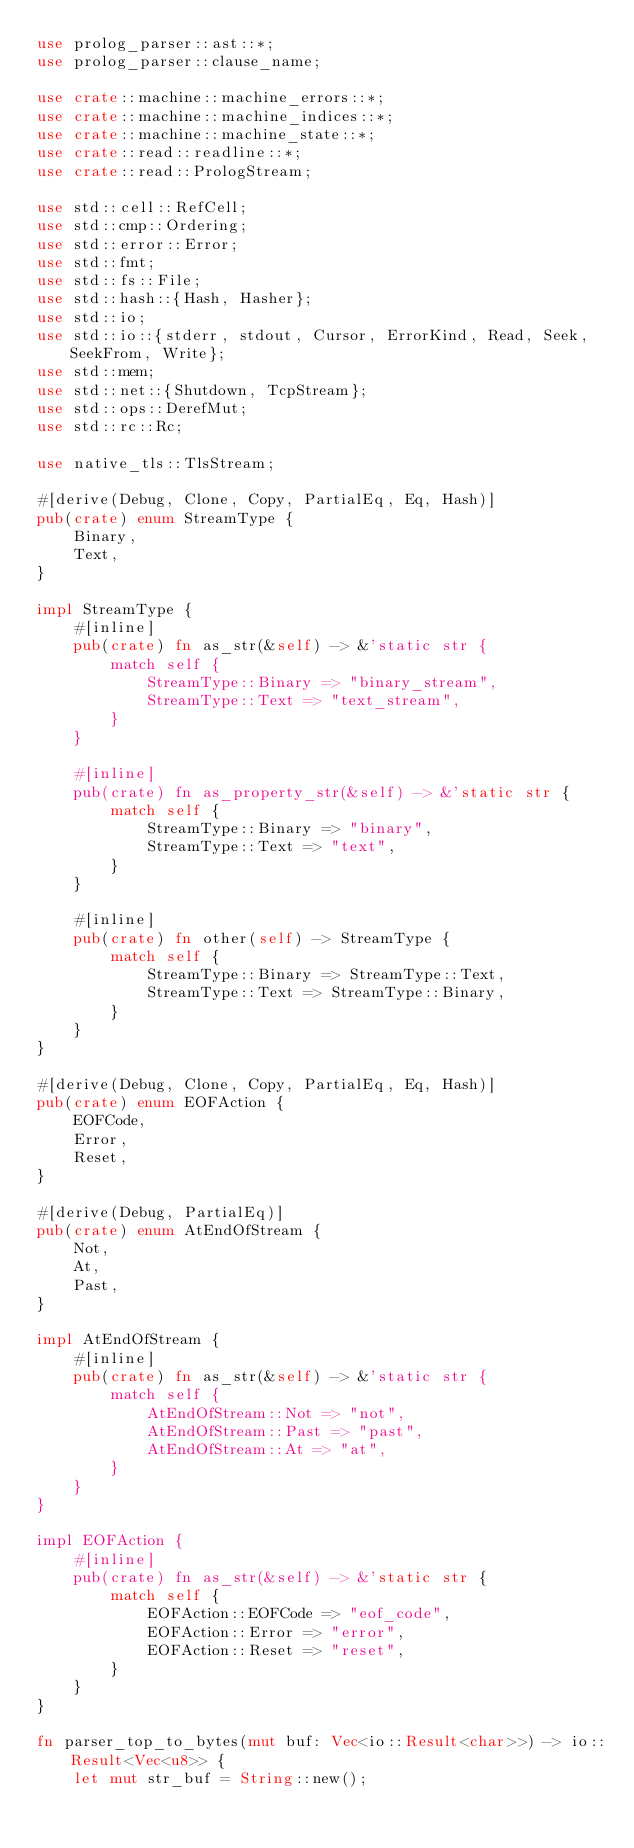<code> <loc_0><loc_0><loc_500><loc_500><_Rust_>use prolog_parser::ast::*;
use prolog_parser::clause_name;

use crate::machine::machine_errors::*;
use crate::machine::machine_indices::*;
use crate::machine::machine_state::*;
use crate::read::readline::*;
use crate::read::PrologStream;

use std::cell::RefCell;
use std::cmp::Ordering;
use std::error::Error;
use std::fmt;
use std::fs::File;
use std::hash::{Hash, Hasher};
use std::io;
use std::io::{stderr, stdout, Cursor, ErrorKind, Read, Seek, SeekFrom, Write};
use std::mem;
use std::net::{Shutdown, TcpStream};
use std::ops::DerefMut;
use std::rc::Rc;

use native_tls::TlsStream;

#[derive(Debug, Clone, Copy, PartialEq, Eq, Hash)]
pub(crate) enum StreamType {
    Binary,
    Text,
}

impl StreamType {
    #[inline]
    pub(crate) fn as_str(&self) -> &'static str {
        match self {
            StreamType::Binary => "binary_stream",
            StreamType::Text => "text_stream",
        }
    }

    #[inline]
    pub(crate) fn as_property_str(&self) -> &'static str {
        match self {
            StreamType::Binary => "binary",
            StreamType::Text => "text",
        }
    }

    #[inline]
    pub(crate) fn other(self) -> StreamType {
        match self {
            StreamType::Binary => StreamType::Text,
            StreamType::Text => StreamType::Binary,
        }
    }
}

#[derive(Debug, Clone, Copy, PartialEq, Eq, Hash)]
pub(crate) enum EOFAction {
    EOFCode,
    Error,
    Reset,
}

#[derive(Debug, PartialEq)]
pub(crate) enum AtEndOfStream {
    Not,
    At,
    Past,
}

impl AtEndOfStream {
    #[inline]
    pub(crate) fn as_str(&self) -> &'static str {
        match self {
            AtEndOfStream::Not => "not",
            AtEndOfStream::Past => "past",
            AtEndOfStream::At => "at",
        }
    }
}

impl EOFAction {
    #[inline]
    pub(crate) fn as_str(&self) -> &'static str {
        match self {
            EOFAction::EOFCode => "eof_code",
            EOFAction::Error => "error",
            EOFAction::Reset => "reset",
        }
    }
}

fn parser_top_to_bytes(mut buf: Vec<io::Result<char>>) -> io::Result<Vec<u8>> {
    let mut str_buf = String::new();
</code> 